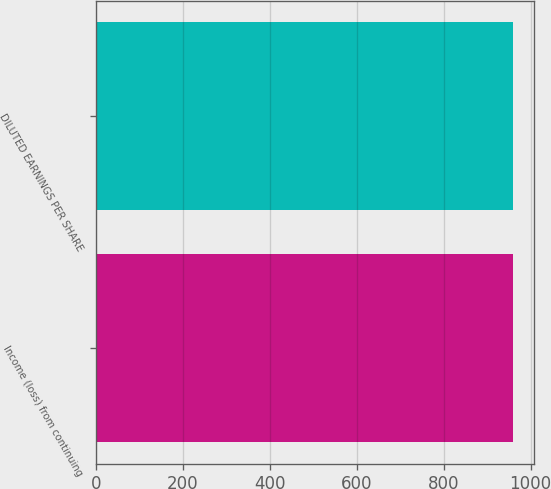Convert chart. <chart><loc_0><loc_0><loc_500><loc_500><bar_chart><fcel>Income (loss) from continuing<fcel>DILUTED EARNINGS PER SHARE<nl><fcel>960<fcel>960.1<nl></chart> 